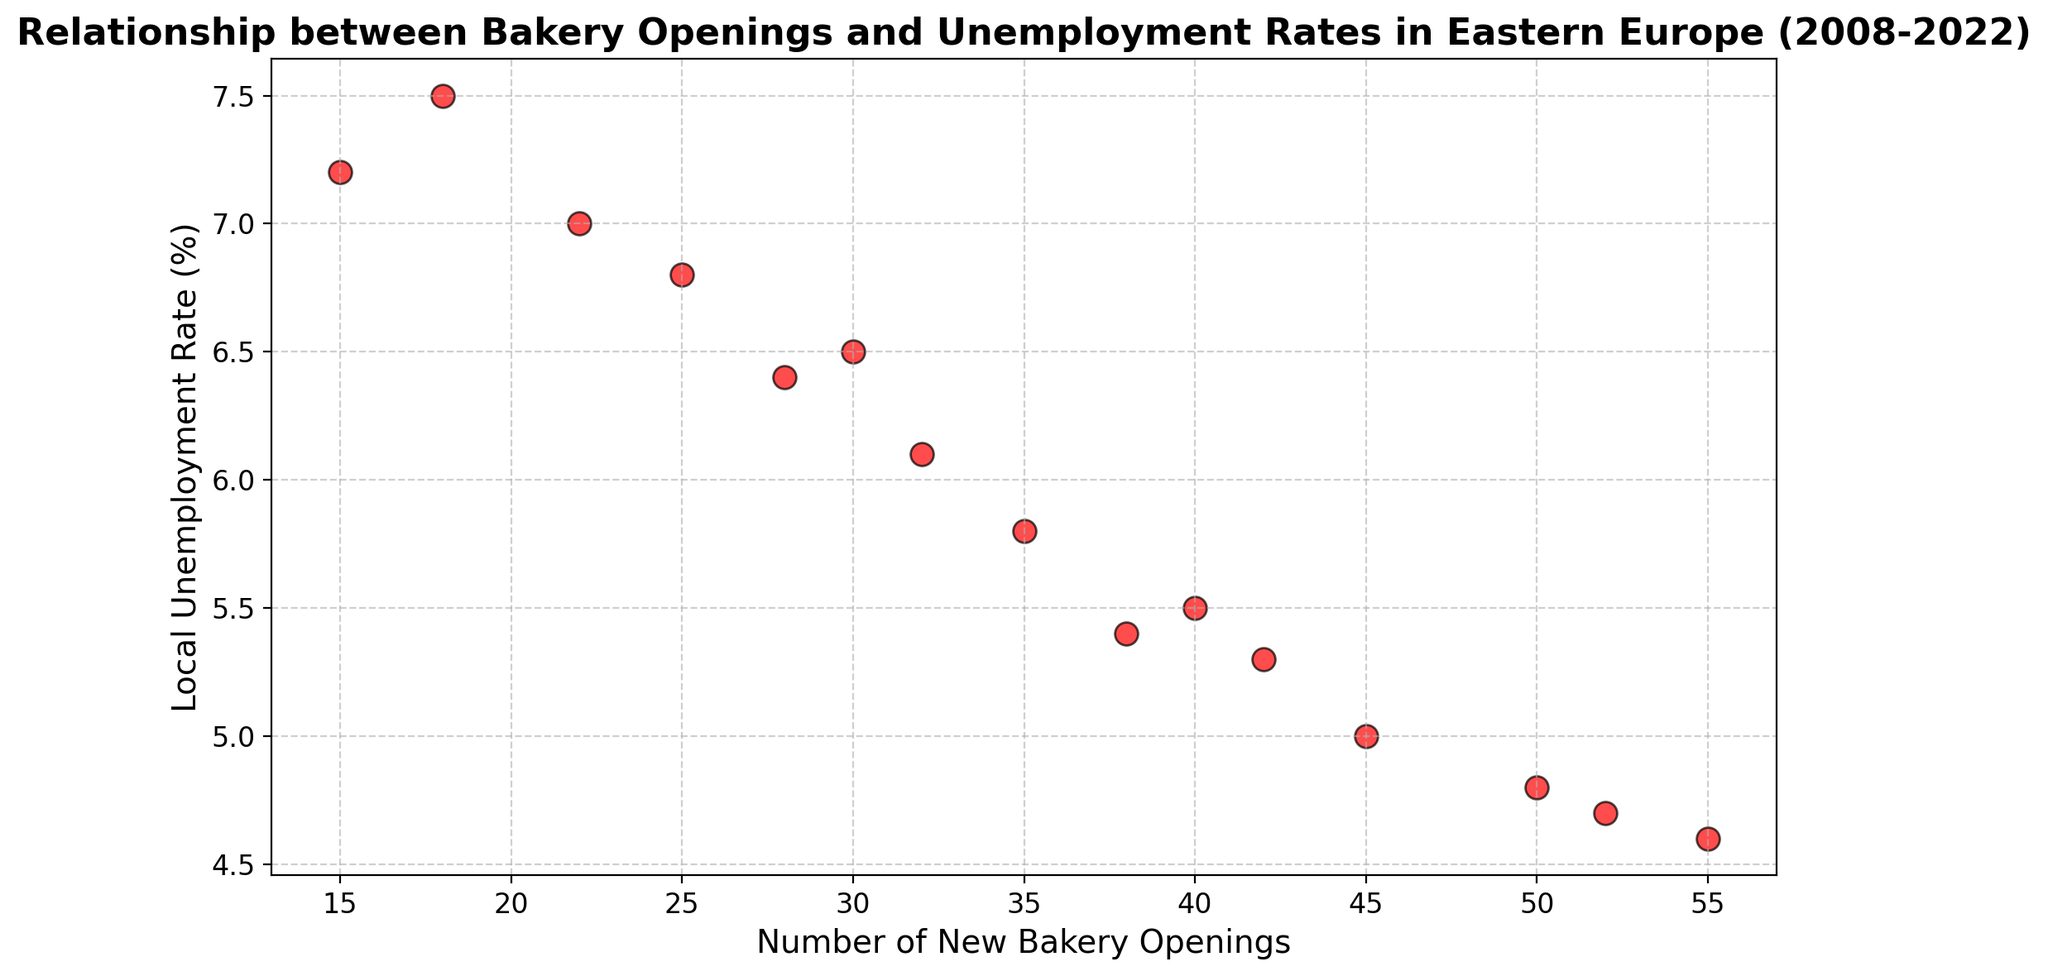What's the trend observed in local unemployment rates as the number of new bakery openings increases? The unemployment rates generally decrease as the number of new bakery openings increase. This can be observed from the scatter plot where points trend downwards on the y-axis as they move rightward on the x-axis.
Answer: Unemployment rates decrease What is the unemployment rate when there were 45 new bakery openings? Find the point on the scatter plot where the x-axis (Number of New Bakery Openings) is 45. Look at the corresponding y-axis value to determine the unemployment rate.
Answer: 5.0% Between 2012 and 2022, how does the number of new bakery openings change compared to the unemployment rate? Identify the points that represent the years 2012 and 2022. Calculate the difference in the Number of New Bakery Openings and in the Local Unemployment Rate. In 2012, there were 30 new bakery openings and the unemployment rate was 6.5%. In 2022, there were 55 new bakery openings and the unemployment rate was 4.6%.
Answer: Number of new bakery openings increased by 25 and unemployment rate decreased by 1.9% Which year had the highest unemployment rate? Find the point with the highest y-axis value (Local Unemployment Rate). Check the x-axis of this point to identify the corresponding year.
Answer: 2009 What visual pattern is evident between the points representing 2017 and 2018? Look at the points on the scatter plot for 2017 and 2018. Notice whether there's an increase or decrease in both the number of new bakery openings and unemployment rates. In 2017, the number of new bakery openings was 42 and the unemployment rate was 5.3%. In 2018, the number was 38 with an unemployment rate of 5.4%.
Answer: Number of new bakery openings decreased, and unemployment rate increased What is the average number of new bakery openings from 2018 to 2022? Determine the number of new bakery openings for the years 2018 (38), 2019 (45), 2020 (50), 2021 (52), and 2022 (55). Calculate the average by summing these values and dividing by 5: (38 + 45 + 50 + 52 + 55)/5.
Answer: 48 Does a lower unemployment rate always correspond to a higher number of new bakery openings? Observe the scatter plot to see if all points with lower unemployment rates (lower y-values) correspond to higher numbers of new bakery openings (higher x-values). Most points show this trend, but note any exceptions.
Answer: Generally, yes Which year had the most significant decrease in unemployment rate from the previous year? Compare the unemployment rates year-over-year to identify which year had the largest drop. Look for the biggest vertical gap between two consecutive points. 2015 to 2016 had the most significant decrease from 5.8% to 5.5%.
Answer: 2016 Is there a visual cluster of points where the number of new bakery openings is above 40? Look for a grouping of points along the x-axis where values are greater than 40. Check if these points are visually clustered together. There appears to be a cluster from 2017 to 2022.
Answer: Yes What is the difference between the unemployment rates when 25 and 50 new bakeries were opened? Locate the points where the number of new bakery openings are 25 and 50 and note their corresponding unemployment rates. Subtract these values: 6.8% (2011) - 4.8% (2020).
Answer: 2% 